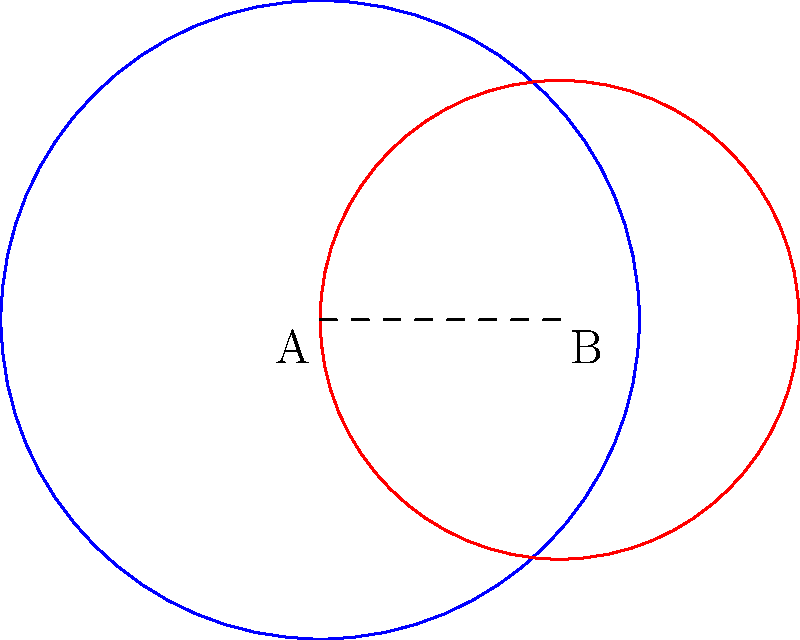Two circles representing competing influences, A and B, overlap as shown. Circle A has a radius of 4 units, and circle B has a radius of 3 units. The centers of the circles are 3 units apart. Calculate the area of overlap between these circles, which represents the region where both influences are present. How could this information be used to undermine Carl's group? To calculate the area of overlap between two circles, we'll use the following steps:

1) First, we need to find the distance between the points of intersection. We can use the formula:

   $$d = 2\sqrt{\frac{(r_1+r_2+a)(r_1-r_2+a)(r_1+r_2-a)(-r_1+r_2+a)}{4a^2}}$$

   where $r_1 = 4$, $r_2 = 3$, and $a = 3$ (distance between centers)

2) Plugging in the values:

   $$d = 2\sqrt{\frac{(4+3+3)(4-3+3)(4+3-3)(-4+3+3)}{4(3^2)}} = 2\sqrt{\frac{10 \cdot 4 \cdot 4 \cdot 2}{36}} = 2\sqrt{\frac{320}{36}} = 2\sqrt{\frac{160}{18}} \approx 3.9791$$

3) Now we can calculate the area of overlap using:

   $$A = r_1^2 \arccos(\frac{a^2 + r_1^2 - r_2^2}{2ar_1}) + r_2^2 \arccos(\frac{a^2 + r_2^2 - r_1^2}{2ar_2}) - \frac{1}{2}\sqrt{(-a+r_1+r_2)(a+r_1-r_2)(a-r_1+r_2)(a+r_1+r_2)}$$

4) Plugging in the values and calculating:

   $$A = 16 \arccos(\frac{9 + 16 - 9}{24}) + 9 \arccos(\frac{9 + 9 - 16}{18}) - \frac{1}{2}\sqrt{(-3+4+3)(3+4-3)(3-4+3)(3+4+3)}$$
   
   $$= 16 \arccos(\frac{2}{3}) + 9 \arccos(\frac{1}{9}) - \frac{1}{2}\sqrt{4 \cdot 4 \cdot 2 \cdot 10}$$
   
   $$\approx 16 \cdot 0.8411 + 9 \cdot 1.4454 - \frac{1}{2} \cdot 7.9583$$
   
   $$\approx 13.4576 + 13.0086 - 3.9791 \approx 22.4871$$

5) Therefore, the area of overlap is approximately 22.4871 square units.

This information could be used to undermine Carl's group by identifying the extent of shared influence or resources between competing factions, potentially exposing vulnerabilities or opportunities for division.
Answer: 22.4871 square units 